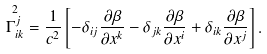<formula> <loc_0><loc_0><loc_500><loc_500>\overset { 2 } { \Gamma _ { i k } ^ { j } } = \frac { 1 } { c ^ { 2 } } \left [ - \delta _ { i j } \frac { \partial \beta } { \partial x ^ { k } } - \delta _ { j k } \frac { \partial \beta } { \partial x ^ { i } } + \delta _ { i k } \frac { \partial \beta } { \partial x ^ { j } } \right ] .</formula> 